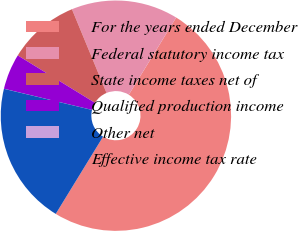Convert chart to OTSL. <chart><loc_0><loc_0><loc_500><loc_500><pie_chart><fcel>For the years ended December<fcel>Federal statutory income tax<fcel>State income taxes net of<fcel>Qualified production income<fcel>Other net<fcel>Effective income tax rate<nl><fcel>49.99%<fcel>15.0%<fcel>10.0%<fcel>5.01%<fcel>0.01%<fcel>20.0%<nl></chart> 